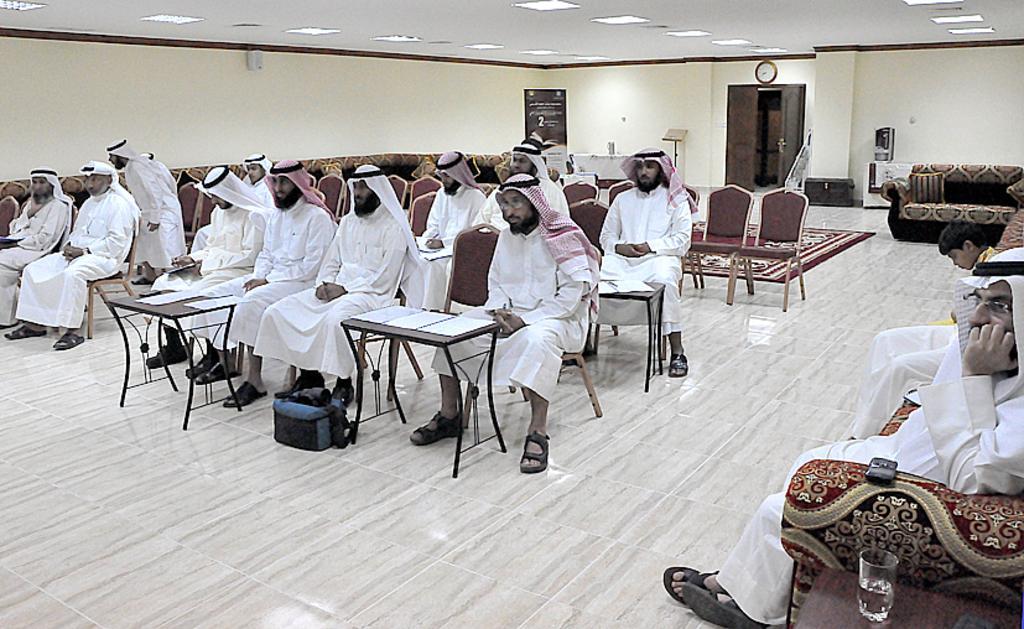Could you give a brief overview of what you see in this image? Here we can see a group of people sitting on chair with tables in front of them having papers on it and on the right side we can see people sitting on couches and we can see glass of water present on the table and behind them we can see door, wall clock and lights on the top present 